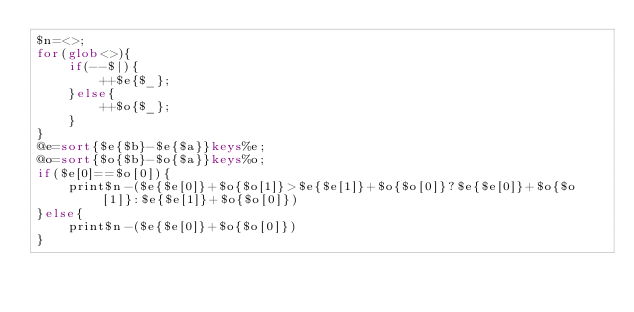<code> <loc_0><loc_0><loc_500><loc_500><_Perl_>$n=<>;
for(glob<>){
	if(--$|){
		++$e{$_};
	}else{
		++$o{$_};
	}
}
@e=sort{$e{$b}-$e{$a}}keys%e;
@o=sort{$o{$b}-$o{$a}}keys%o;
if($e[0]==$o[0]){
	print$n-($e{$e[0]}+$o{$o[1]}>$e{$e[1]}+$o{$o[0]}?$e{$e[0]}+$o{$o[1]}:$e{$e[1]}+$o{$o[0]})
}else{
	print$n-($e{$e[0]}+$o{$o[0]})
}
</code> 